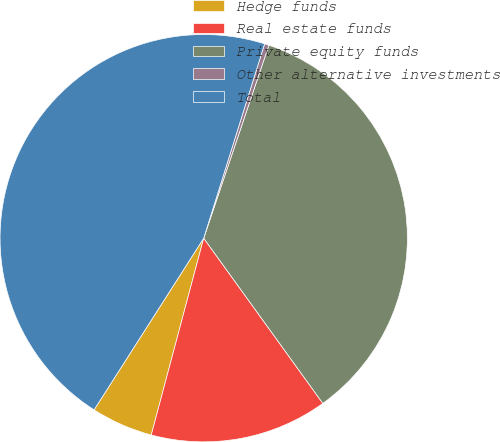Convert chart. <chart><loc_0><loc_0><loc_500><loc_500><pie_chart><fcel>Hedge funds<fcel>Real estate funds<fcel>Private equity funds<fcel>Other alternative investments<fcel>Total<nl><fcel>4.9%<fcel>14.09%<fcel>34.87%<fcel>0.35%<fcel>45.79%<nl></chart> 